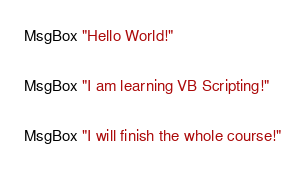<code> <loc_0><loc_0><loc_500><loc_500><_VisualBasic_>MsgBox "Hello World!"

MsgBox "I am learning VB Scripting!"

MsgBox "I will finish the whole course!"</code> 